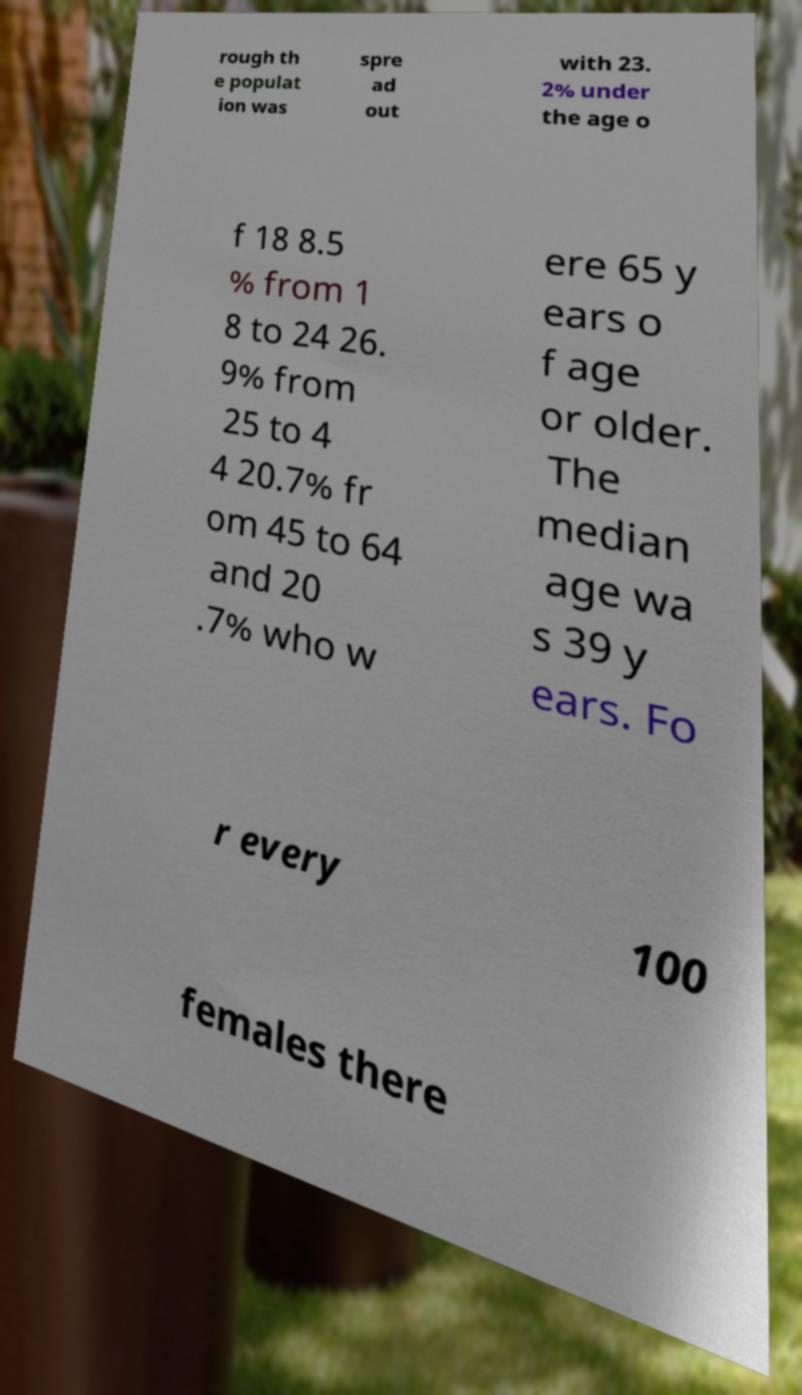Please identify and transcribe the text found in this image. rough th e populat ion was spre ad out with 23. 2% under the age o f 18 8.5 % from 1 8 to 24 26. 9% from 25 to 4 4 20.7% fr om 45 to 64 and 20 .7% who w ere 65 y ears o f age or older. The median age wa s 39 y ears. Fo r every 100 females there 